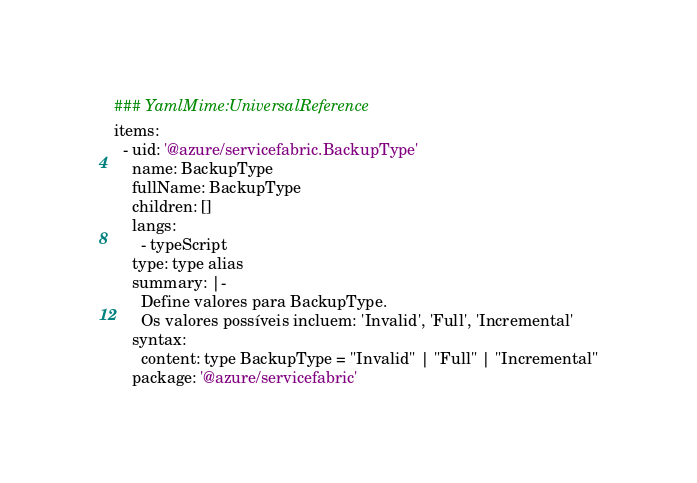<code> <loc_0><loc_0><loc_500><loc_500><_YAML_>### YamlMime:UniversalReference
items:
  - uid: '@azure/servicefabric.BackupType'
    name: BackupType
    fullName: BackupType
    children: []
    langs:
      - typeScript
    type: type alias
    summary: |-
      Define valores para BackupType.
      Os valores possíveis incluem: 'Invalid', 'Full', 'Incremental'
    syntax:
      content: type BackupType = "Invalid" | "Full" | "Incremental"
    package: '@azure/servicefabric'</code> 